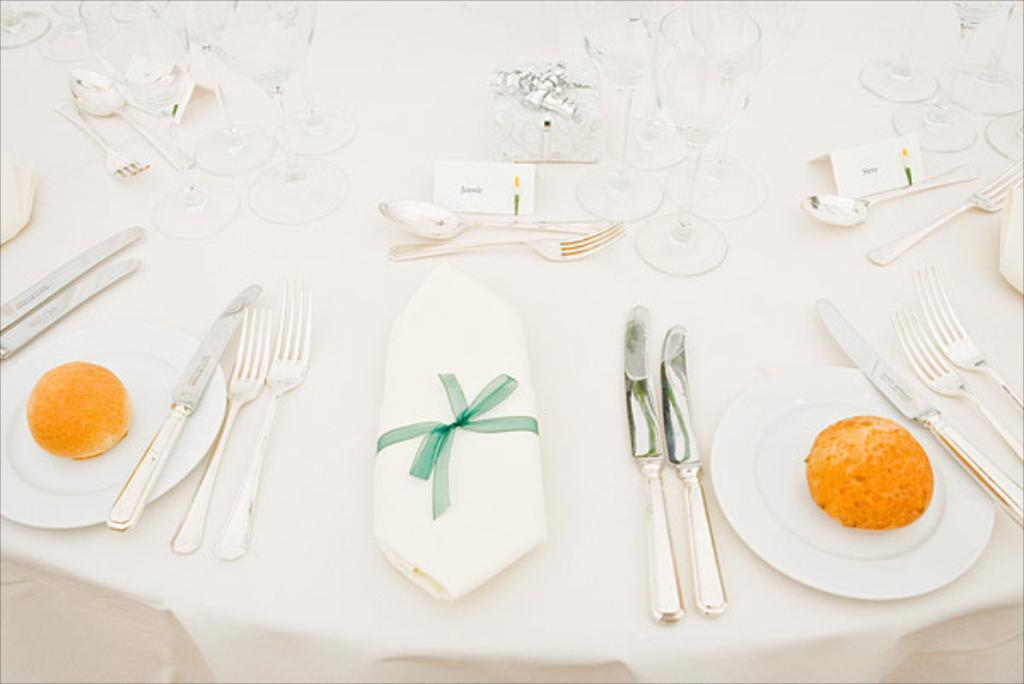What is on the plates that are visible in the image? There are two plates with food in the image. What utensils can be seen in the image? Knives and forks are visible in the image. What type of containers are present in the image? There are boards and glasses in the image. What is the color of the object with a ribbon in the image? The object with a ribbon is white in color. What is the surface that the objects are placed on in the image? The objects are on a white color surface. Can you describe the pear that is on the table in the image? There is no pear present in the image. What type of spade is being used to dig in the garden in the image? There is no garden or spade present in the image. 